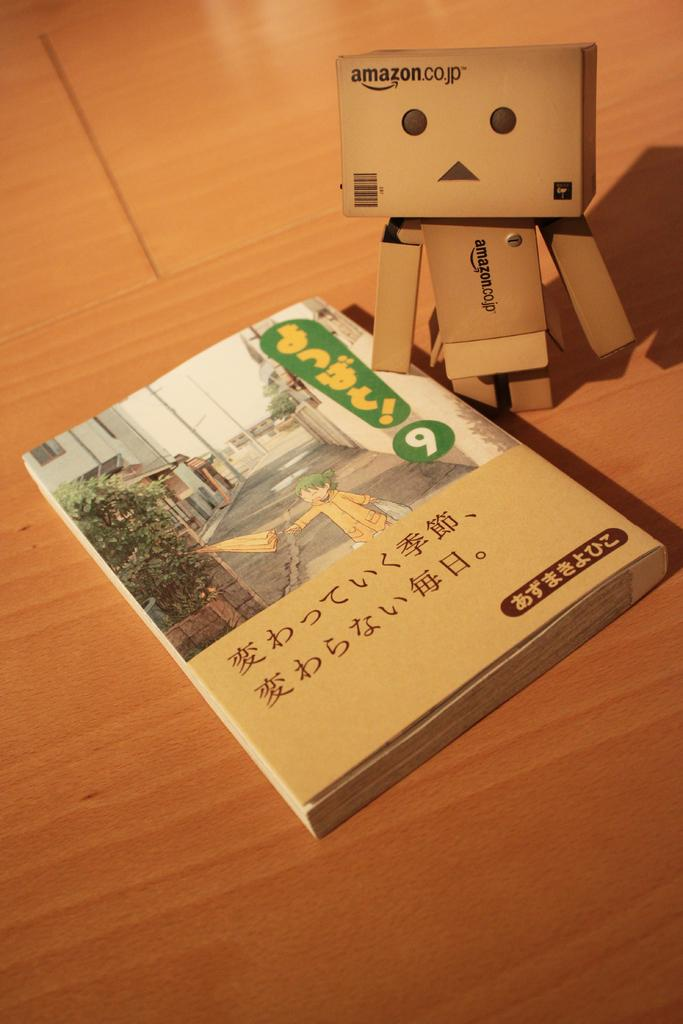<image>
Present a compact description of the photo's key features. A book sits next to an amazon.co.jp robot 